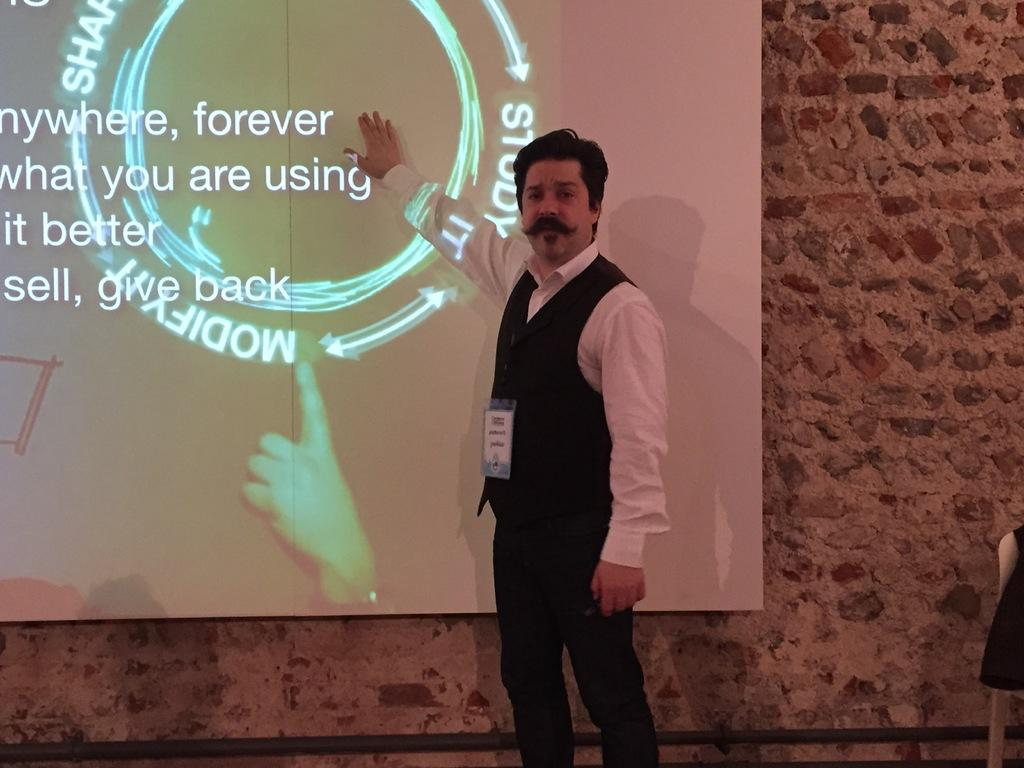Who is present in the image? There is a person in the image. What is the person wearing that can be seen in the image? The person is wearing an ID card. What can be seen in the background of the image? There is a wall and a screen in the background of the image, along with other objects. What type of feast is being prepared in the image? There is no indication of a feast or any food preparation in the image. 